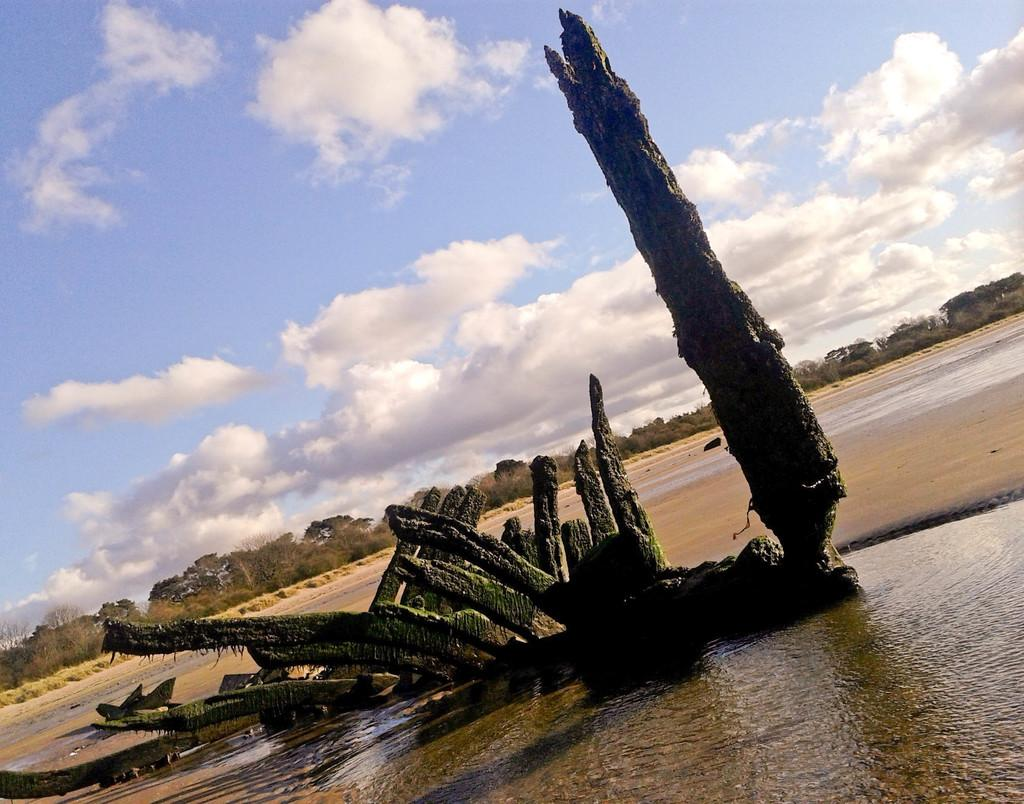What is the primary element in the image? There is water in the image. What can be seen in the water? There is a tree covered with algae in the water. What is visible in the background of the image? There are trees and the sky visible in the background of the image. What word is being used to create harmony in the image? There is no word or concept of harmony present in the image; it is a natural scene featuring water, a tree, and algae. 